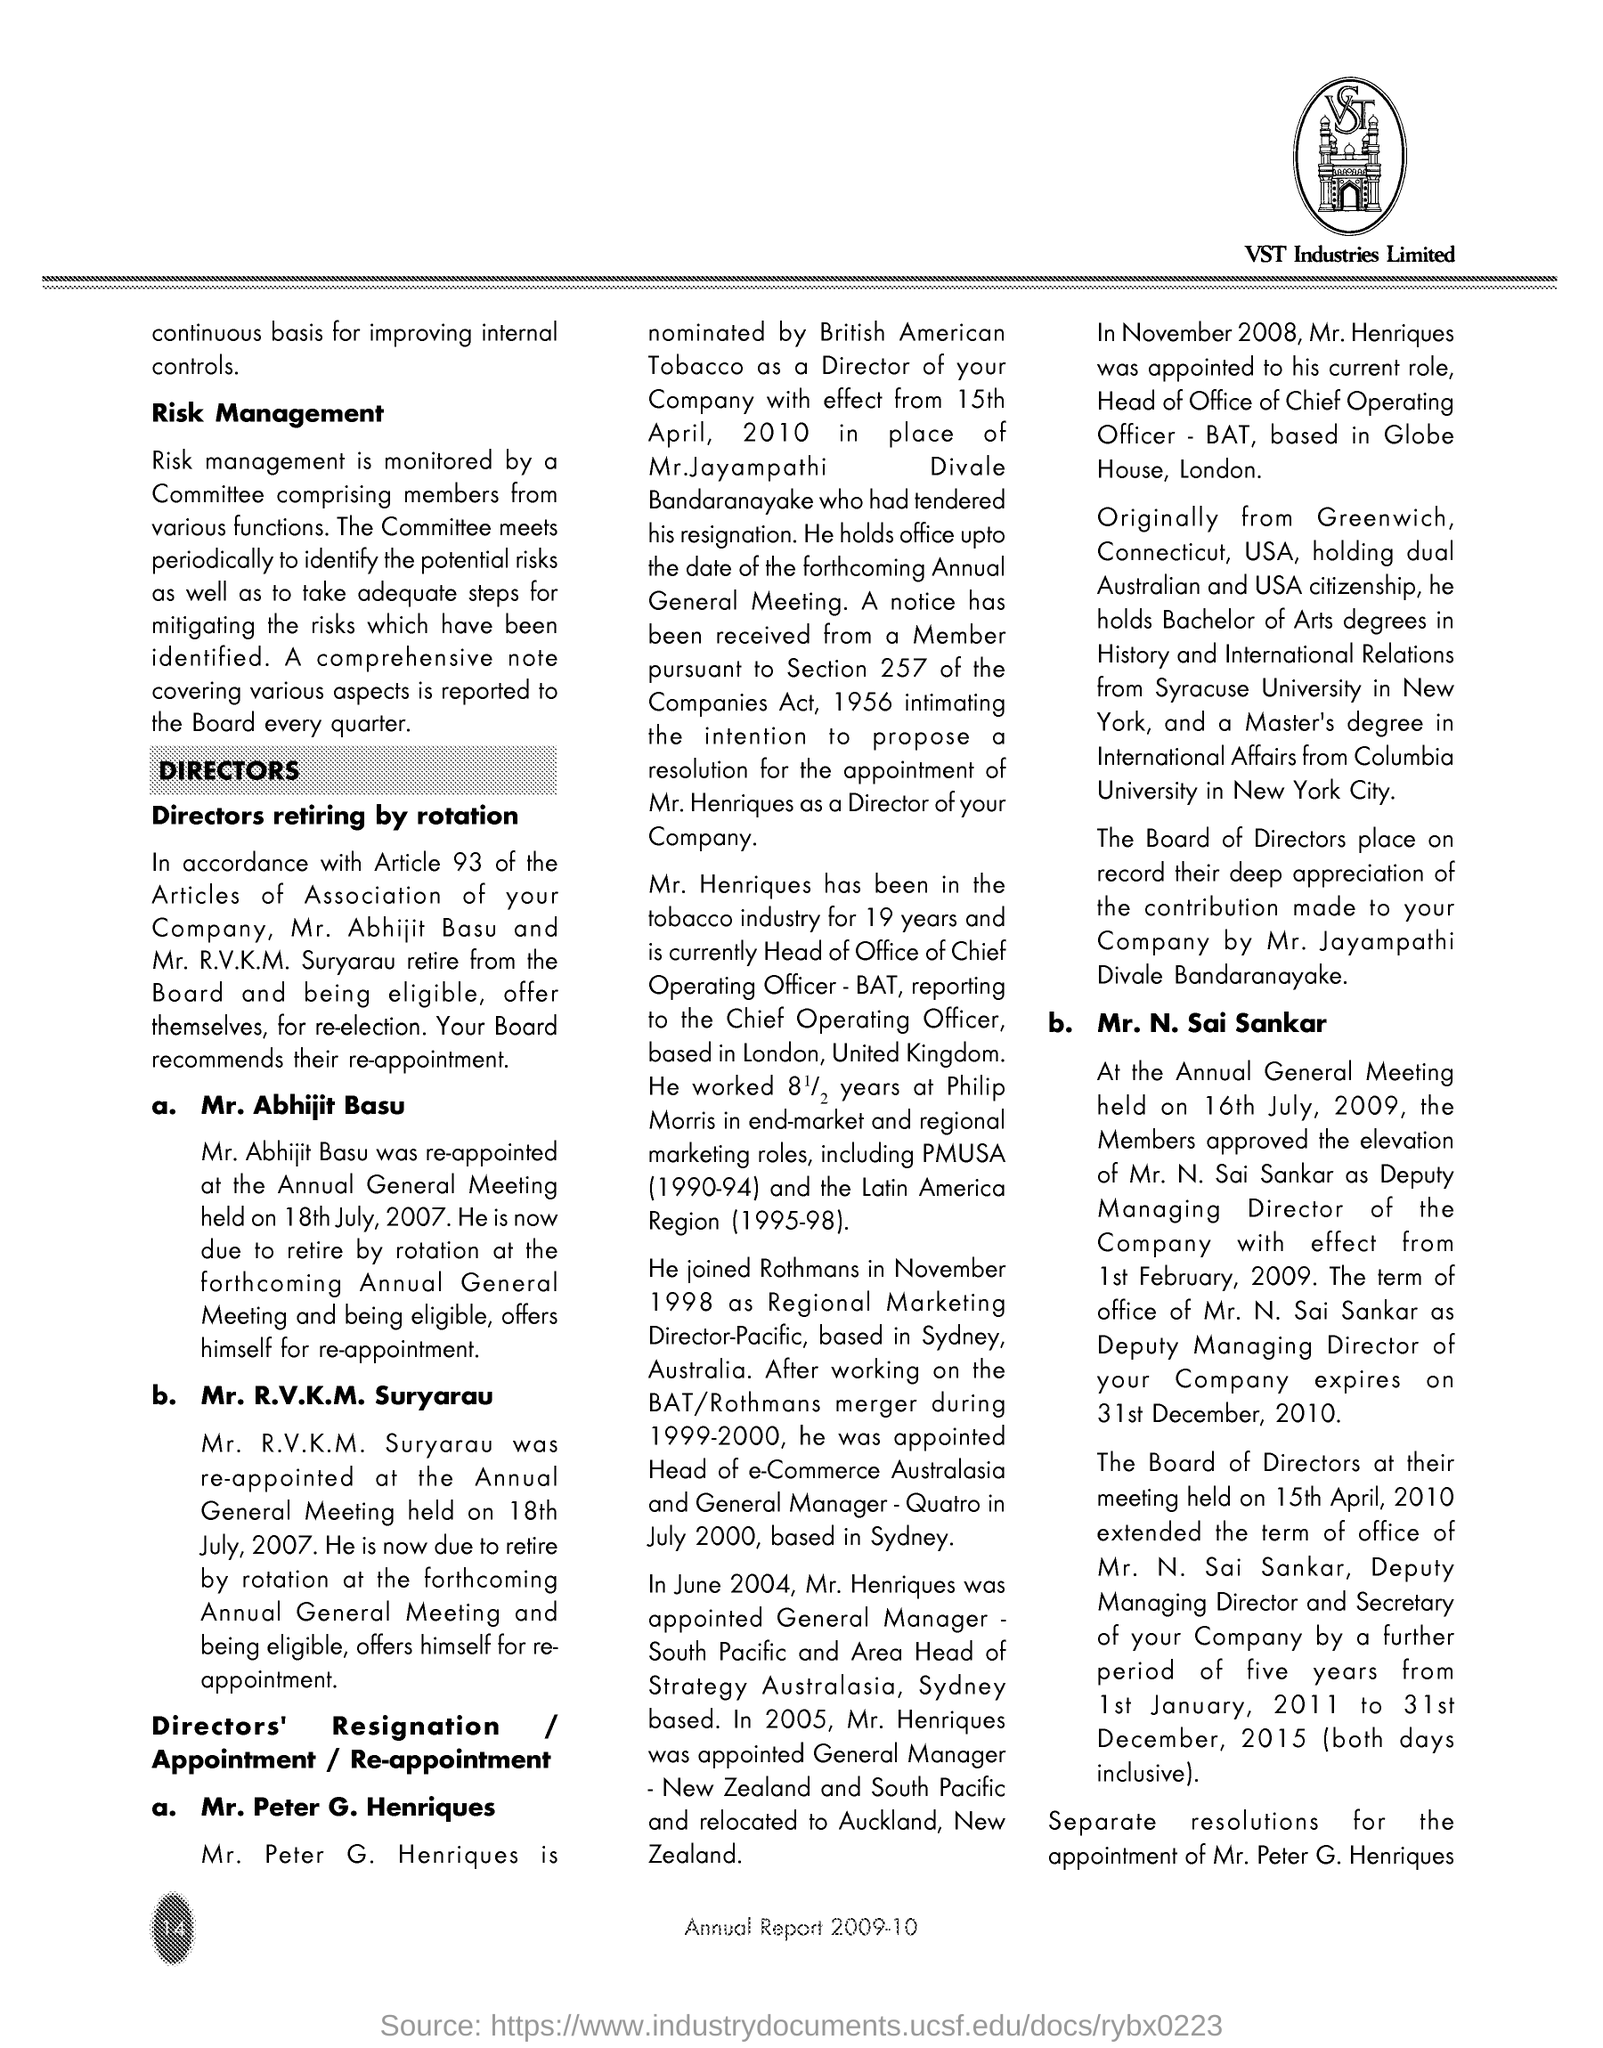Mention the name of the company written under the logo?
Keep it short and to the point. VST Industries Limited. What is written within logo, given at the right top corner of the page?
Make the answer very short. VST. "Annual Report" of which year is given in the document?(See bottom of the page)
Your response must be concise. 2009-10. Mention the first subheading given?
Your answer should be compact. Risk Management. At which meeting "Mr. Abhijit Basu was re-appointed"?
Your answer should be compact. Annual General Meeting. On which date was "Mr. R.V.K.M.  Suryarau re-appointed?
Provide a short and direct response. 18th July , 2007. Who nominated "Mr. Peter G. Henriques"?
Offer a very short reply. British American Tobacco. How many years "Mr. Peter G. Henriques has been in tobacco industry"?
Keep it short and to the point. 19. On which date members approved the elevation of Mr. N.  Sai Sankar as  "Deputy Managing Director of the company?
Offer a very short reply. 16th July, 2009. 